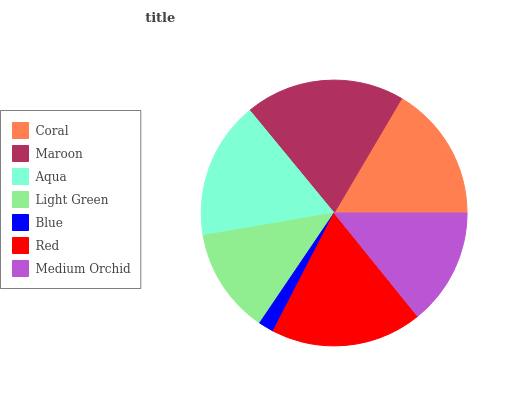Is Blue the minimum?
Answer yes or no. Yes. Is Maroon the maximum?
Answer yes or no. Yes. Is Aqua the minimum?
Answer yes or no. No. Is Aqua the maximum?
Answer yes or no. No. Is Maroon greater than Aqua?
Answer yes or no. Yes. Is Aqua less than Maroon?
Answer yes or no. Yes. Is Aqua greater than Maroon?
Answer yes or no. No. Is Maroon less than Aqua?
Answer yes or no. No. Is Coral the high median?
Answer yes or no. Yes. Is Coral the low median?
Answer yes or no. Yes. Is Medium Orchid the high median?
Answer yes or no. No. Is Aqua the low median?
Answer yes or no. No. 